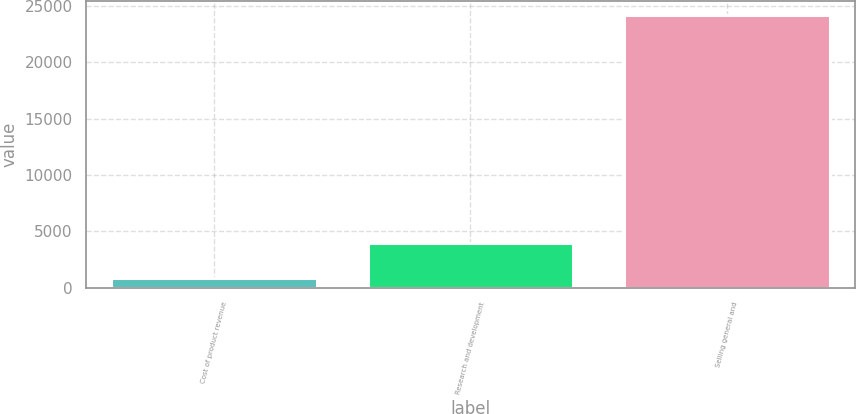Convert chart to OTSL. <chart><loc_0><loc_0><loc_500><loc_500><bar_chart><fcel>Cost of product revenue<fcel>Research and development<fcel>Selling general and<nl><fcel>895<fcel>3950<fcel>24208<nl></chart> 